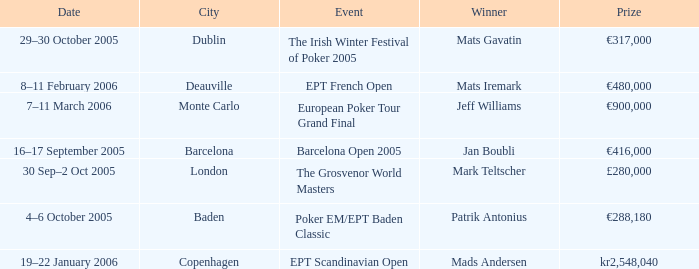What city did an event have a prize of €288,180? Baden. 